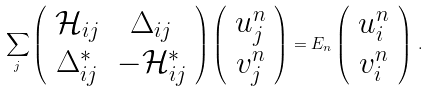<formula> <loc_0><loc_0><loc_500><loc_500>\sum _ { j } \left ( \begin{array} { c c } { \mathcal { H } } _ { i j } & \Delta _ { i j } \\ \Delta _ { i j } ^ { * } & - { \mathcal { H } } _ { i j } ^ { * } \end{array} \right ) \left ( \begin{array} { c } u _ { j } ^ { n } \\ v _ { j } ^ { n } \end{array} \right ) = E _ { n } \left ( \begin{array} { c } u _ { i } ^ { n } \\ v _ { i } ^ { n } \end{array} \right ) \, .</formula> 